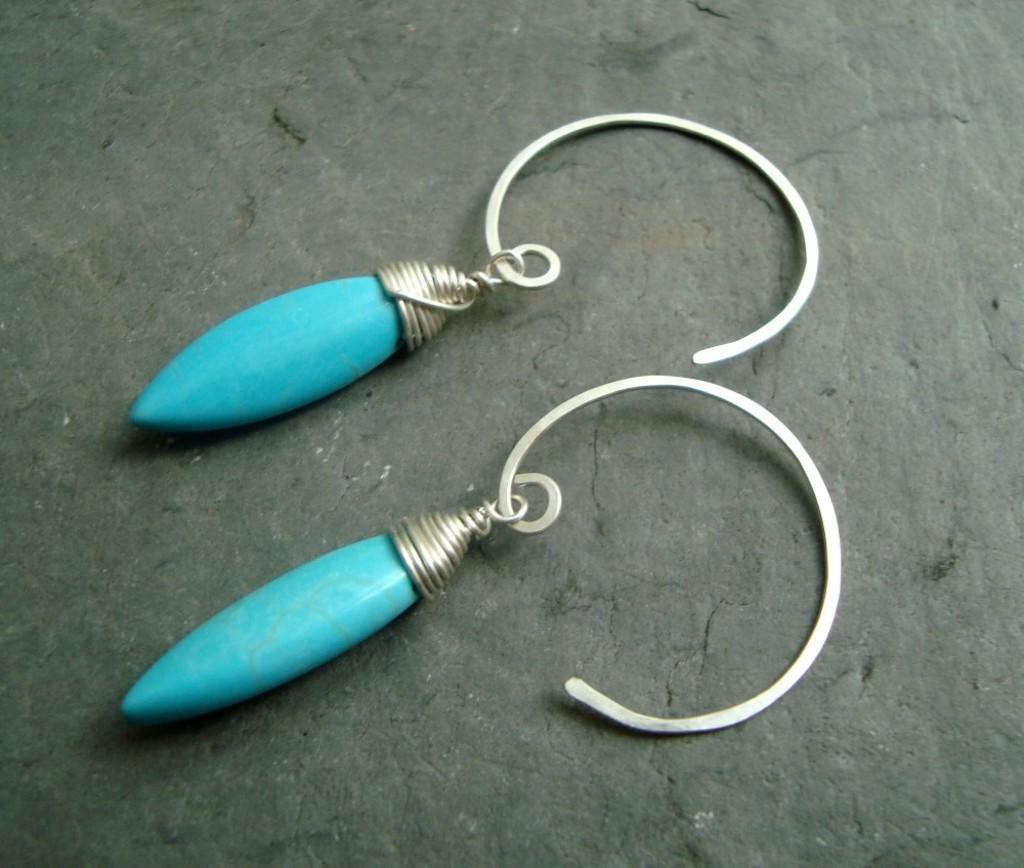Can you describe this image briefly? This image consists of two earrings. They are in blue color. 